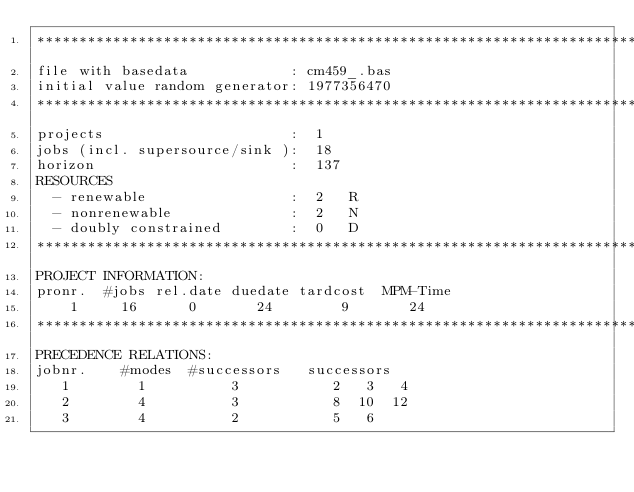Convert code to text. <code><loc_0><loc_0><loc_500><loc_500><_ObjectiveC_>************************************************************************
file with basedata            : cm459_.bas
initial value random generator: 1977356470
************************************************************************
projects                      :  1
jobs (incl. supersource/sink ):  18
horizon                       :  137
RESOURCES
  - renewable                 :  2   R
  - nonrenewable              :  2   N
  - doubly constrained        :  0   D
************************************************************************
PROJECT INFORMATION:
pronr.  #jobs rel.date duedate tardcost  MPM-Time
    1     16      0       24        9       24
************************************************************************
PRECEDENCE RELATIONS:
jobnr.    #modes  #successors   successors
   1        1          3           2   3   4
   2        4          3           8  10  12
   3        4          2           5   6</code> 